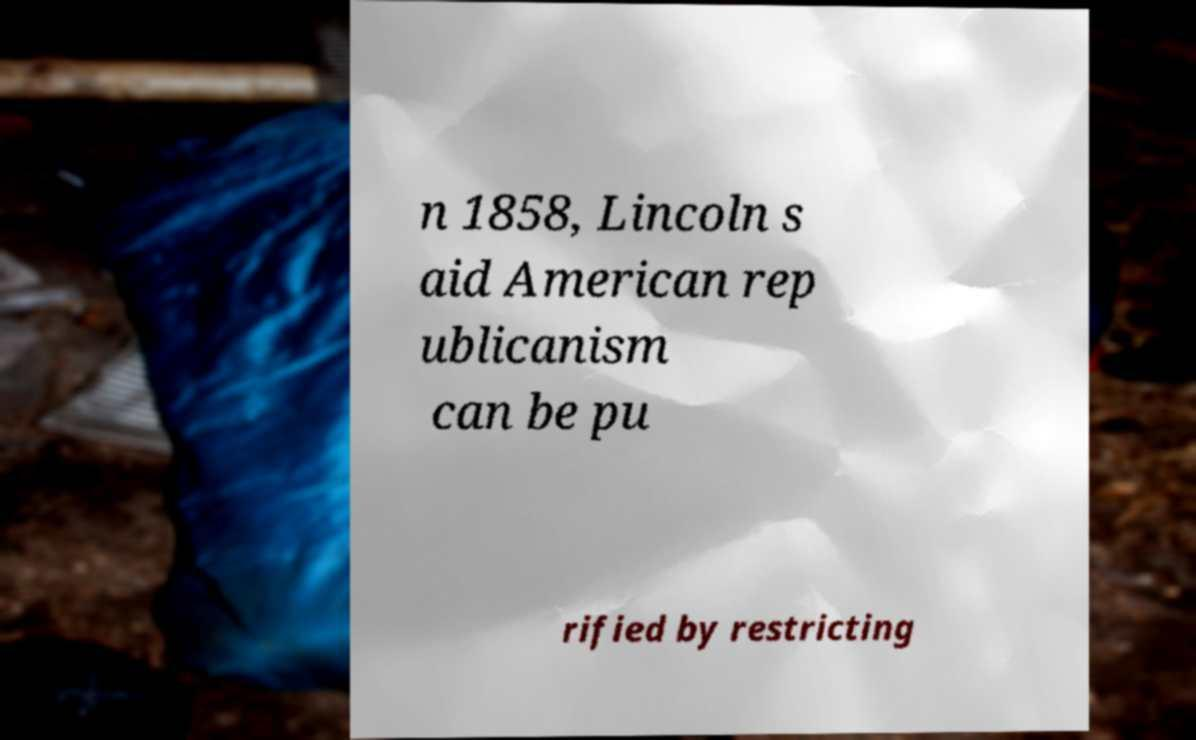Please read and relay the text visible in this image. What does it say? n 1858, Lincoln s aid American rep ublicanism can be pu rified by restricting 